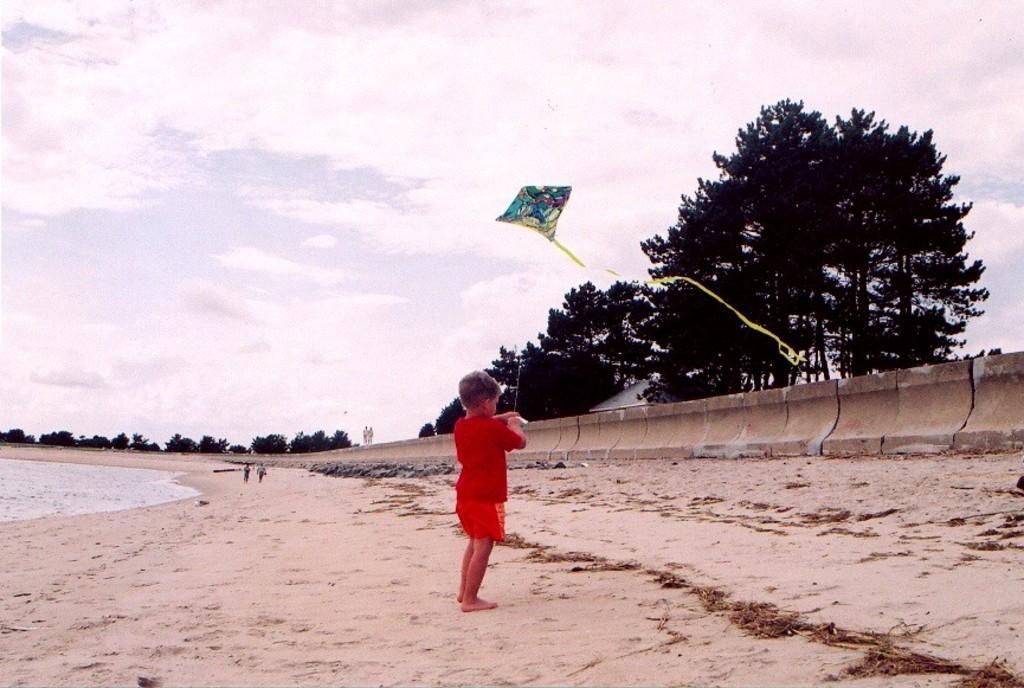In one or two sentences, can you explain what this image depicts? In the center of the image there is a kid standing on the sand holding a kite. In the background we can see trees, house, sky and clouds. On the left side of the image there is water and persons. 